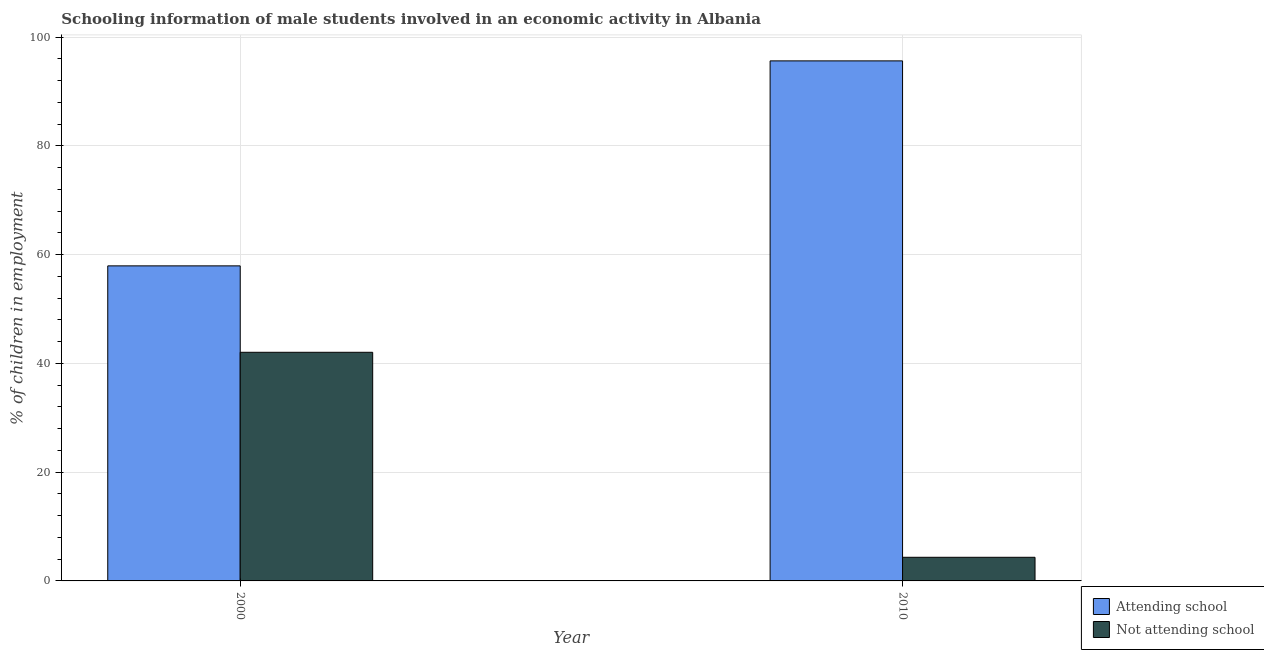How many different coloured bars are there?
Your answer should be very brief. 2. How many groups of bars are there?
Keep it short and to the point. 2. Are the number of bars per tick equal to the number of legend labels?
Give a very brief answer. Yes. What is the percentage of employed males who are not attending school in 2010?
Offer a very short reply. 4.35. Across all years, what is the maximum percentage of employed males who are attending school?
Make the answer very short. 95.65. Across all years, what is the minimum percentage of employed males who are not attending school?
Your response must be concise. 4.35. What is the total percentage of employed males who are not attending school in the graph?
Your answer should be compact. 46.4. What is the difference between the percentage of employed males who are not attending school in 2000 and that in 2010?
Your answer should be very brief. 37.7. What is the difference between the percentage of employed males who are attending school in 2010 and the percentage of employed males who are not attending school in 2000?
Offer a very short reply. 37.7. What is the average percentage of employed males who are not attending school per year?
Offer a very short reply. 23.2. In how many years, is the percentage of employed males who are attending school greater than 92 %?
Your answer should be compact. 1. What is the ratio of the percentage of employed males who are attending school in 2000 to that in 2010?
Provide a short and direct response. 0.61. Is the percentage of employed males who are attending school in 2000 less than that in 2010?
Keep it short and to the point. Yes. In how many years, is the percentage of employed males who are attending school greater than the average percentage of employed males who are attending school taken over all years?
Provide a short and direct response. 1. What does the 2nd bar from the left in 2010 represents?
Offer a terse response. Not attending school. What does the 1st bar from the right in 2000 represents?
Ensure brevity in your answer.  Not attending school. How many bars are there?
Your response must be concise. 4. Are all the bars in the graph horizontal?
Ensure brevity in your answer.  No. How many years are there in the graph?
Ensure brevity in your answer.  2. What is the difference between two consecutive major ticks on the Y-axis?
Your answer should be very brief. 20. Does the graph contain any zero values?
Provide a short and direct response. No. What is the title of the graph?
Your answer should be very brief. Schooling information of male students involved in an economic activity in Albania. Does "Lowest 10% of population" appear as one of the legend labels in the graph?
Offer a very short reply. No. What is the label or title of the Y-axis?
Provide a succinct answer. % of children in employment. What is the % of children in employment of Attending school in 2000?
Offer a very short reply. 57.95. What is the % of children in employment in Not attending school in 2000?
Keep it short and to the point. 42.05. What is the % of children in employment of Attending school in 2010?
Offer a very short reply. 95.65. What is the % of children in employment of Not attending school in 2010?
Keep it short and to the point. 4.35. Across all years, what is the maximum % of children in employment in Attending school?
Give a very brief answer. 95.65. Across all years, what is the maximum % of children in employment of Not attending school?
Make the answer very short. 42.05. Across all years, what is the minimum % of children in employment of Attending school?
Ensure brevity in your answer.  57.95. Across all years, what is the minimum % of children in employment of Not attending school?
Provide a short and direct response. 4.35. What is the total % of children in employment of Attending school in the graph?
Keep it short and to the point. 153.6. What is the total % of children in employment of Not attending school in the graph?
Make the answer very short. 46.4. What is the difference between the % of children in employment in Attending school in 2000 and that in 2010?
Offer a terse response. -37.7. What is the difference between the % of children in employment in Not attending school in 2000 and that in 2010?
Give a very brief answer. 37.7. What is the difference between the % of children in employment of Attending school in 2000 and the % of children in employment of Not attending school in 2010?
Offer a terse response. 53.6. What is the average % of children in employment in Attending school per year?
Ensure brevity in your answer.  76.8. What is the average % of children in employment in Not attending school per year?
Provide a short and direct response. 23.2. In the year 2000, what is the difference between the % of children in employment in Attending school and % of children in employment in Not attending school?
Ensure brevity in your answer.  15.9. In the year 2010, what is the difference between the % of children in employment in Attending school and % of children in employment in Not attending school?
Make the answer very short. 91.31. What is the ratio of the % of children in employment in Attending school in 2000 to that in 2010?
Provide a succinct answer. 0.61. What is the ratio of the % of children in employment of Not attending school in 2000 to that in 2010?
Your answer should be compact. 9.67. What is the difference between the highest and the second highest % of children in employment in Attending school?
Offer a terse response. 37.7. What is the difference between the highest and the second highest % of children in employment in Not attending school?
Make the answer very short. 37.7. What is the difference between the highest and the lowest % of children in employment in Attending school?
Offer a very short reply. 37.7. What is the difference between the highest and the lowest % of children in employment of Not attending school?
Ensure brevity in your answer.  37.7. 